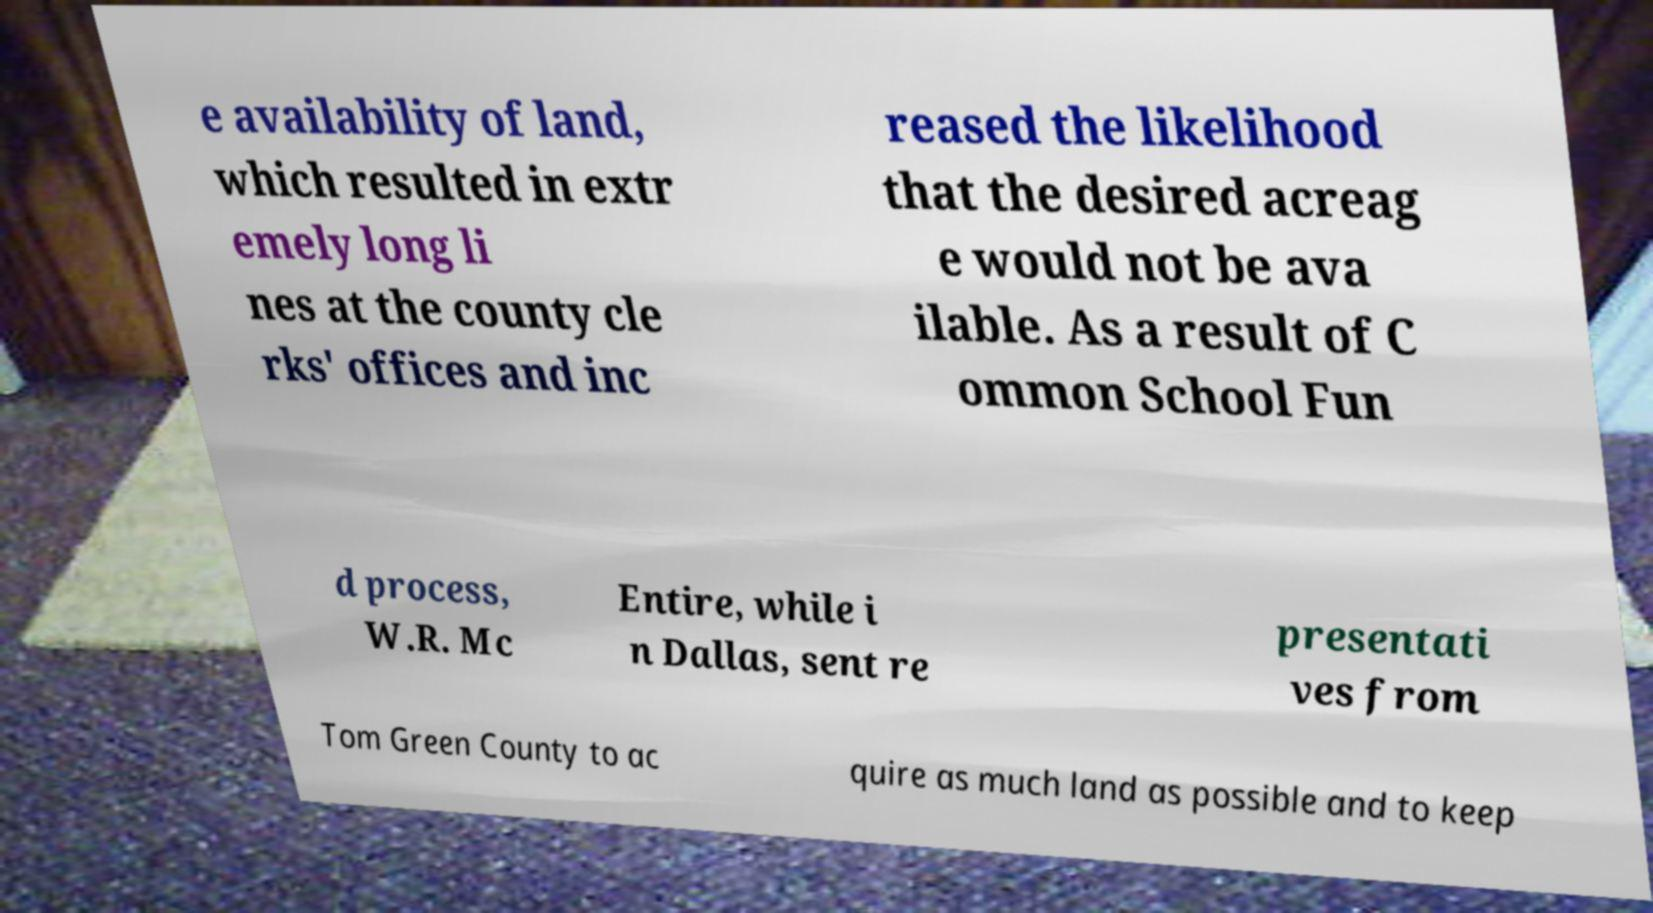Please identify and transcribe the text found in this image. e availability of land, which resulted in extr emely long li nes at the county cle rks' offices and inc reased the likelihood that the desired acreag e would not be ava ilable. As a result of C ommon School Fun d process, W.R. Mc Entire, while i n Dallas, sent re presentati ves from Tom Green County to ac quire as much land as possible and to keep 